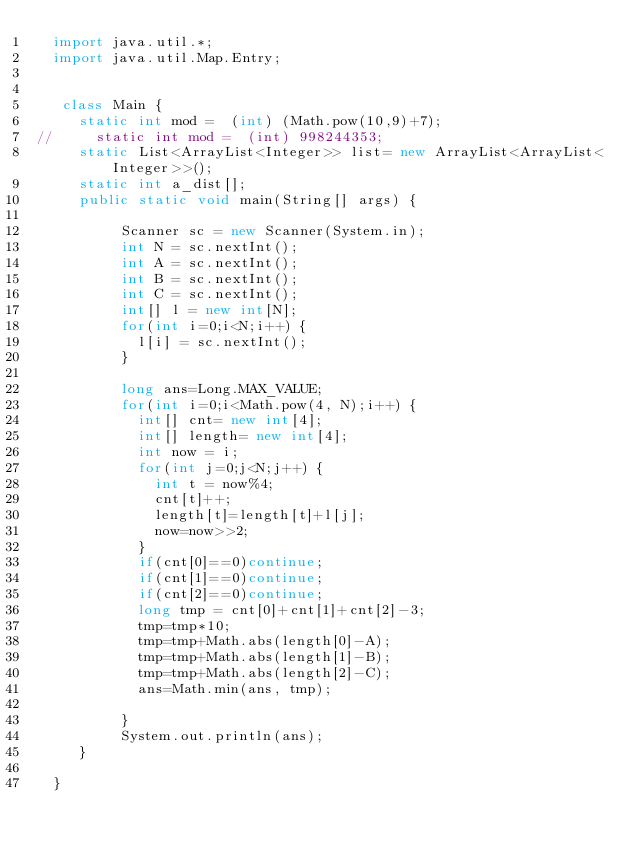Convert code to text. <code><loc_0><loc_0><loc_500><loc_500><_Java_>	import java.util.*;
	import java.util.Map.Entry;
	 
	 
	 class Main {
		 static int mod =  (int) (Math.pow(10,9)+7);
//		 static int mod =  (int) 998244353;
		 static List<ArrayList<Integer>> list= new ArrayList<ArrayList<Integer>>();
		 static int a_dist[];
		 public static void main(String[] args) {
	    	
	        Scanner sc = new Scanner(System.in);
	        int N = sc.nextInt();
	        int A = sc.nextInt();
	        int B = sc.nextInt();
	        int C = sc.nextInt();
	        int[] l = new int[N];
	        for(int i=0;i<N;i++) {
	        	l[i] = sc.nextInt();
	        }
	        
	        long ans=Long.MAX_VALUE;
	        for(int i=0;i<Math.pow(4, N);i++) {
		        int[] cnt= new int[4];
		        int[] length= new int[4];
	        	int now = i;
	        	for(int j=0;j<N;j++) {
	        		int t = now%4;
	        		cnt[t]++;
	        		length[t]=length[t]+l[j];
	        		now=now>>2;
	        	}
	        	if(cnt[0]==0)continue;
	        	if(cnt[1]==0)continue;
	        	if(cnt[2]==0)continue;
	        	long tmp = cnt[0]+cnt[1]+cnt[2]-3;
	        	tmp=tmp*10;
	        	tmp=tmp+Math.abs(length[0]-A);
	        	tmp=tmp+Math.abs(length[1]-B);
	        	tmp=tmp+Math.abs(length[2]-C);
	        	ans=Math.min(ans, tmp);
	        	
	        }
	        System.out.println(ans);
		 }
		 
	}</code> 